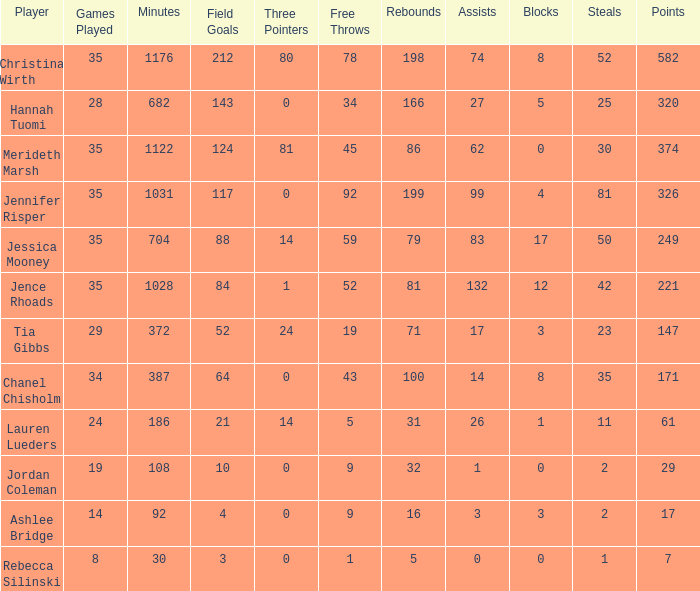For how long did Jordan Coleman play? 108.0. 